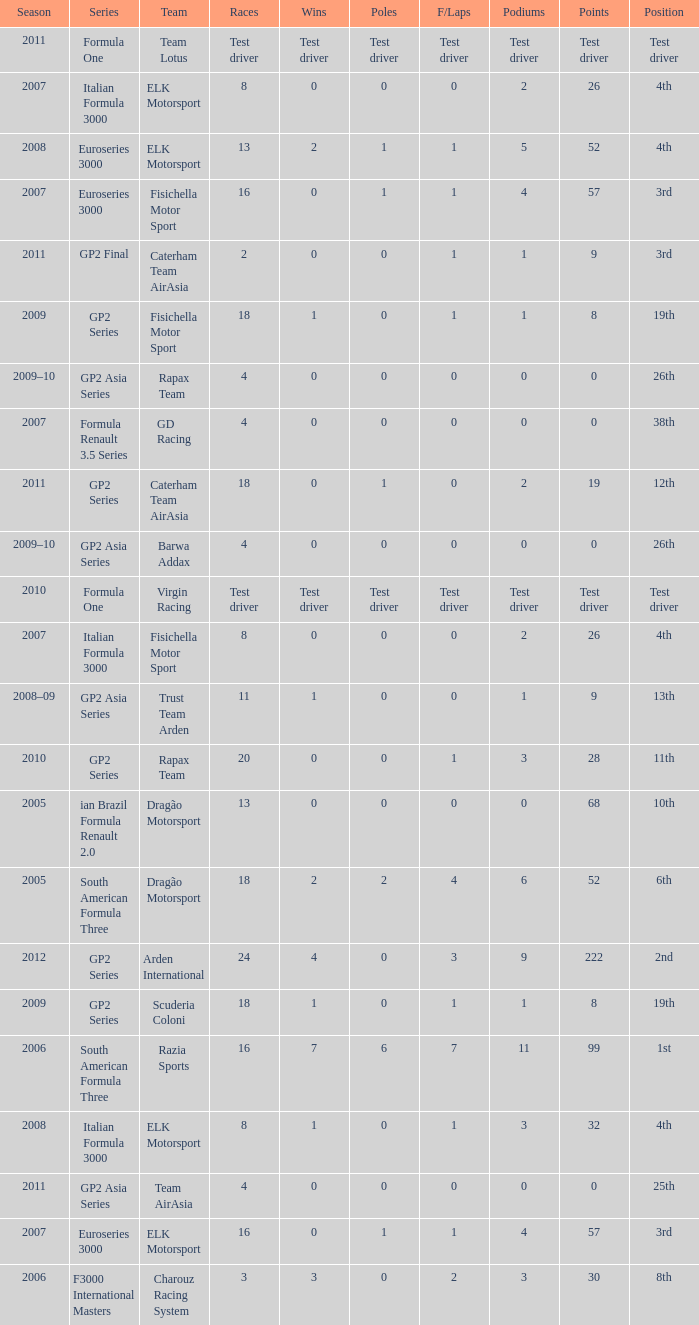What were the points in the year when his Wins were 0, his Podiums were 0, and he drove in 4 races? 0, 0, 0, 0. 